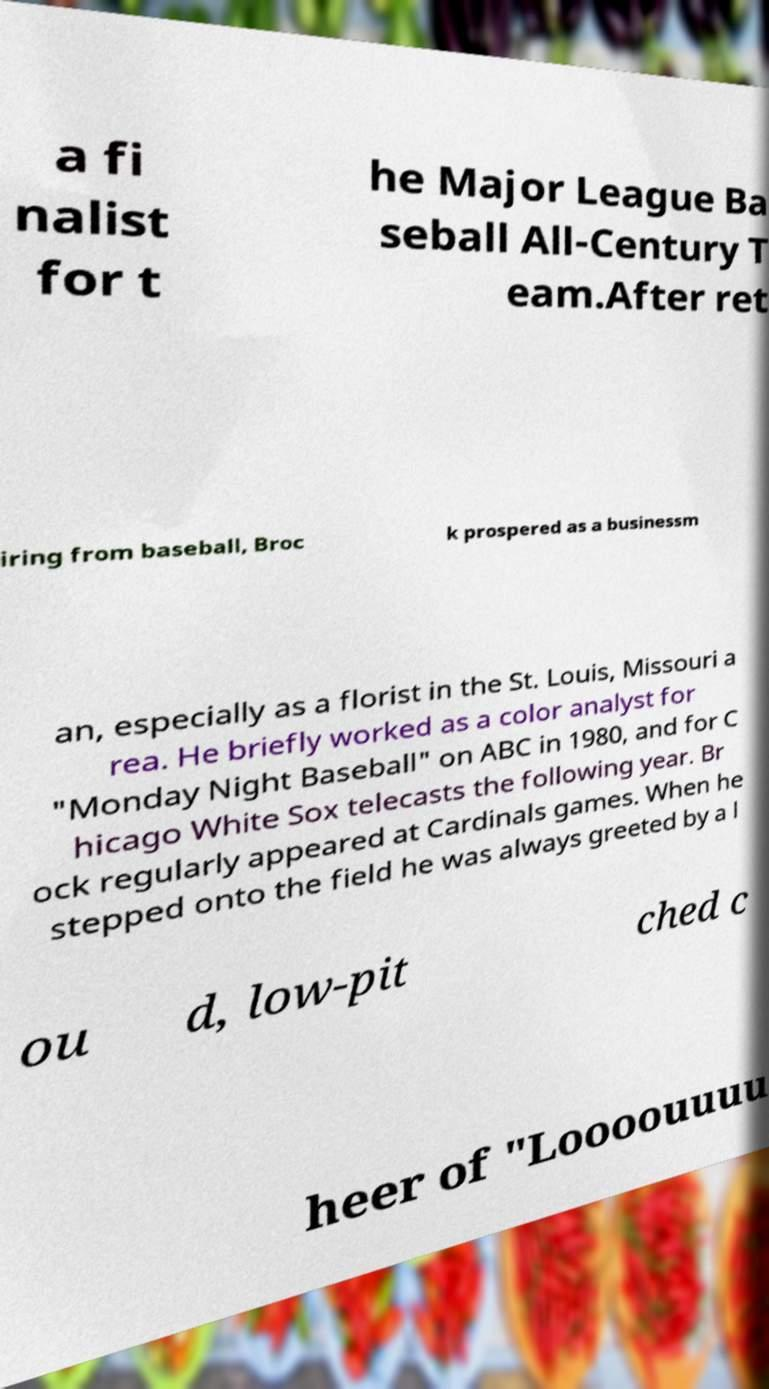I need the written content from this picture converted into text. Can you do that? a fi nalist for t he Major League Ba seball All-Century T eam.After ret iring from baseball, Broc k prospered as a businessm an, especially as a florist in the St. Louis, Missouri a rea. He briefly worked as a color analyst for "Monday Night Baseball" on ABC in 1980, and for C hicago White Sox telecasts the following year. Br ock regularly appeared at Cardinals games. When he stepped onto the field he was always greeted by a l ou d, low-pit ched c heer of "Loooouuuu 